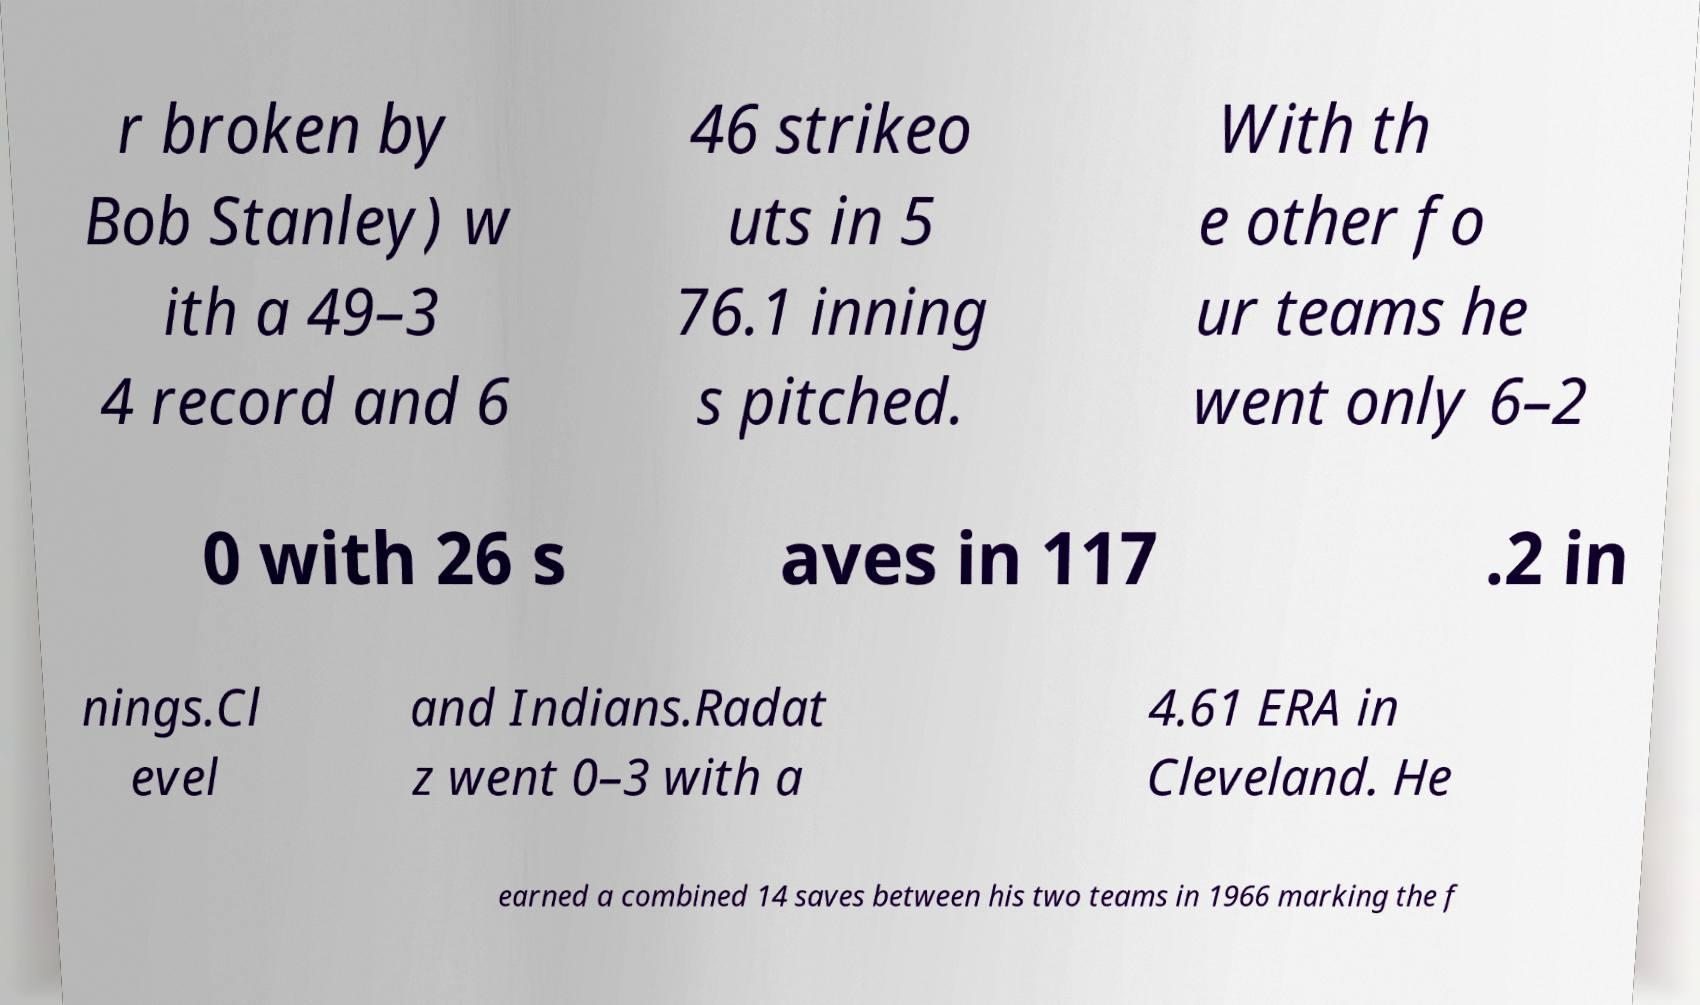What messages or text are displayed in this image? I need them in a readable, typed format. r broken by Bob Stanley) w ith a 49–3 4 record and 6 46 strikeo uts in 5 76.1 inning s pitched. With th e other fo ur teams he went only 6–2 0 with 26 s aves in 117 .2 in nings.Cl evel and Indians.Radat z went 0–3 with a 4.61 ERA in Cleveland. He earned a combined 14 saves between his two teams in 1966 marking the f 